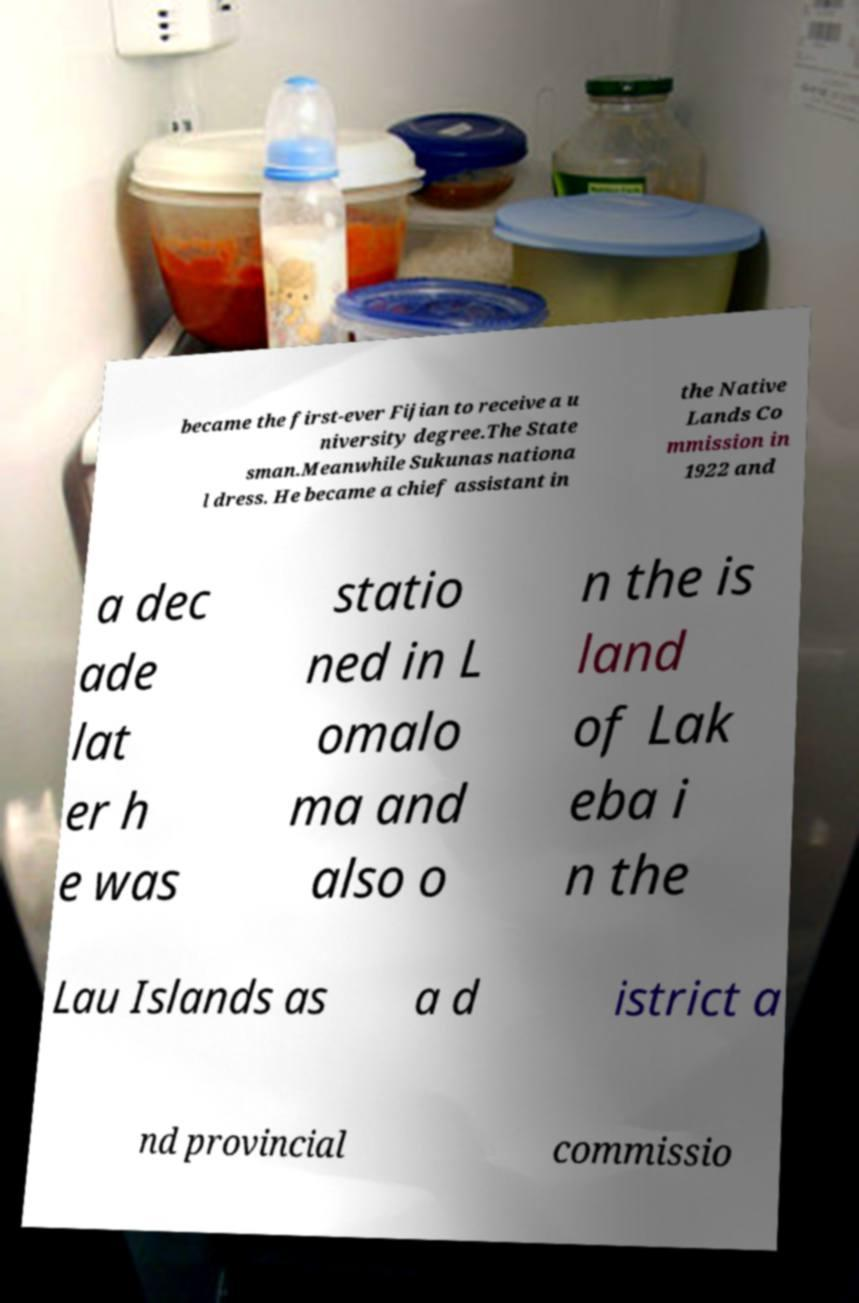Could you extract and type out the text from this image? became the first-ever Fijian to receive a u niversity degree.The State sman.Meanwhile Sukunas nationa l dress. He became a chief assistant in the Native Lands Co mmission in 1922 and a dec ade lat er h e was statio ned in L omalo ma and also o n the is land of Lak eba i n the Lau Islands as a d istrict a nd provincial commissio 